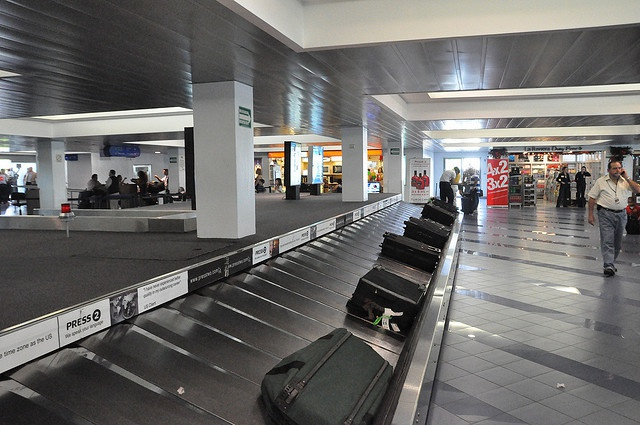Describe the objects in this image and their specific colors. I can see suitcase in black and gray tones, suitcase in black, gray, and darkgray tones, people in black, gray, darkgray, and tan tones, suitcase in black, gray, and darkgray tones, and suitcase in black and gray tones in this image. 